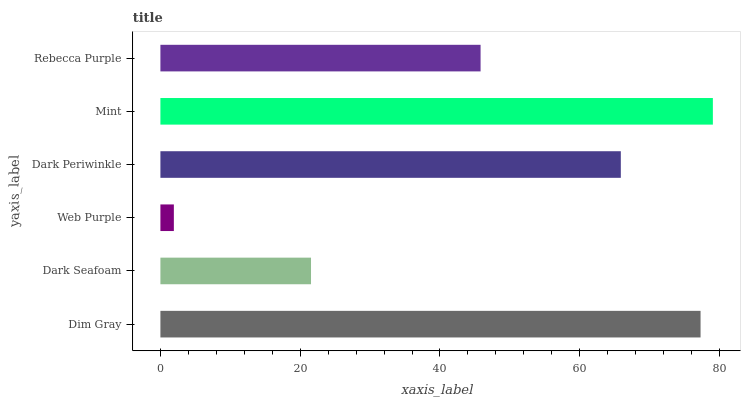Is Web Purple the minimum?
Answer yes or no. Yes. Is Mint the maximum?
Answer yes or no. Yes. Is Dark Seafoam the minimum?
Answer yes or no. No. Is Dark Seafoam the maximum?
Answer yes or no. No. Is Dim Gray greater than Dark Seafoam?
Answer yes or no. Yes. Is Dark Seafoam less than Dim Gray?
Answer yes or no. Yes. Is Dark Seafoam greater than Dim Gray?
Answer yes or no. No. Is Dim Gray less than Dark Seafoam?
Answer yes or no. No. Is Dark Periwinkle the high median?
Answer yes or no. Yes. Is Rebecca Purple the low median?
Answer yes or no. Yes. Is Dim Gray the high median?
Answer yes or no. No. Is Dark Periwinkle the low median?
Answer yes or no. No. 